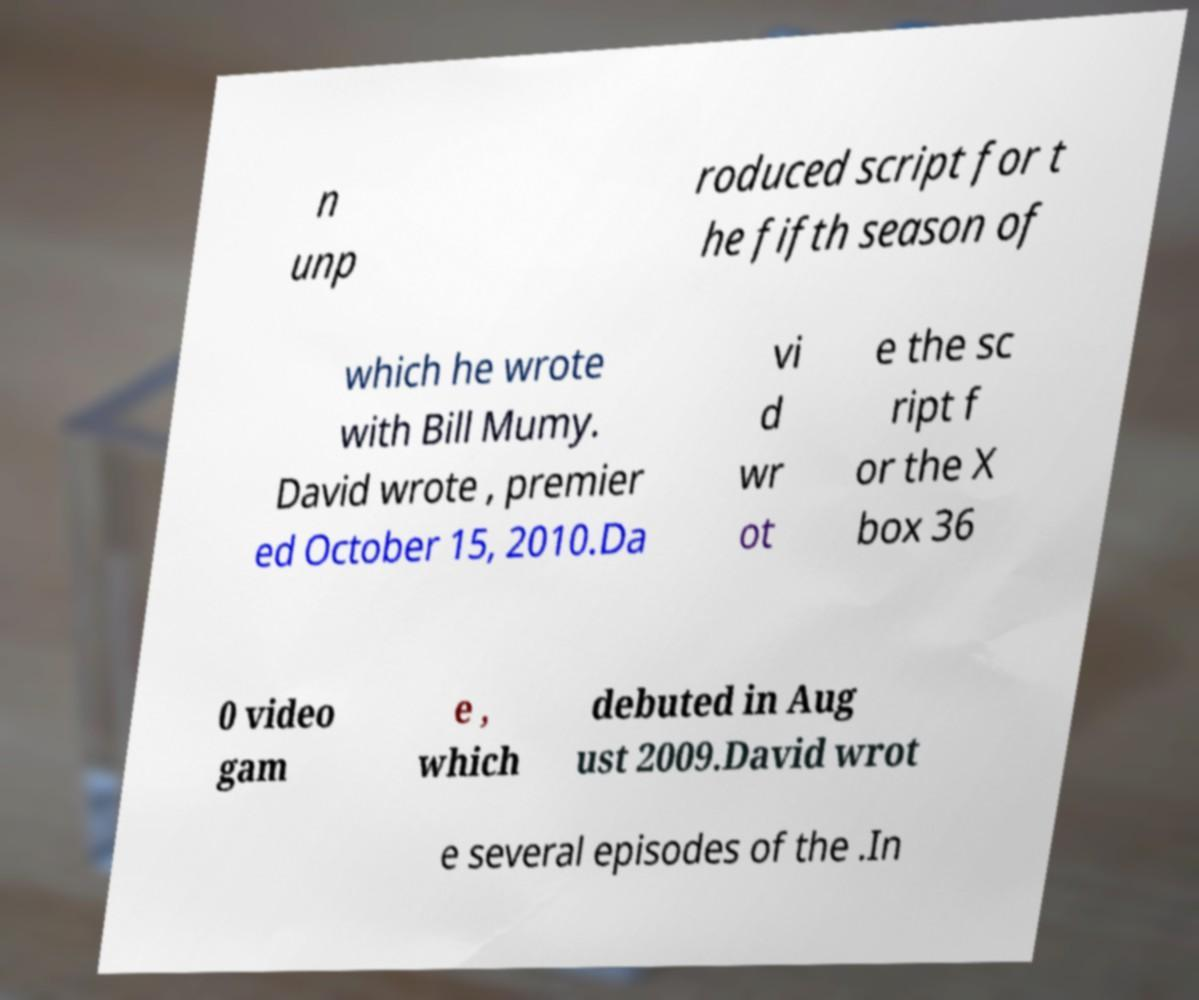Could you assist in decoding the text presented in this image and type it out clearly? n unp roduced script for t he fifth season of which he wrote with Bill Mumy. David wrote , premier ed October 15, 2010.Da vi d wr ot e the sc ript f or the X box 36 0 video gam e , which debuted in Aug ust 2009.David wrot e several episodes of the .In 